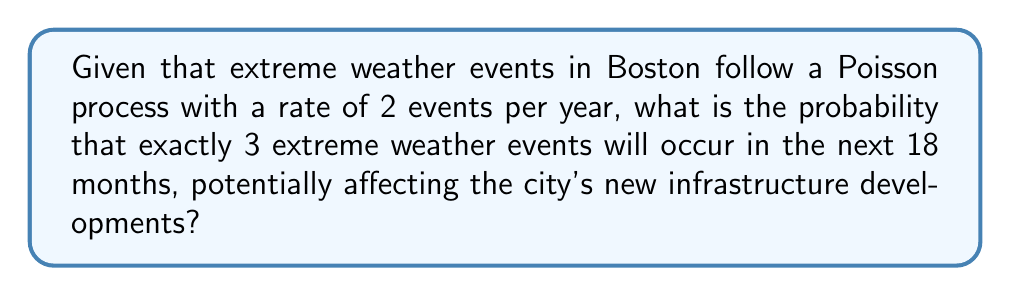Provide a solution to this math problem. Let's approach this step-by-step:

1) First, we need to adjust the rate for the given time period. The rate is 2 events per year, but we're looking at an 18-month period.

   $\lambda = 2 \text{ events/year} \times 1.5 \text{ years} = 3 \text{ events}$

2) The probability of exactly $k$ events occurring in a Poisson process is given by the formula:

   $$P(X = k) = \frac{e^{-\lambda}\lambda^k}{k!}$$

   Where $\lambda$ is the average number of events in the given time period, and $k$ is the number of events we're interested in.

3) In this case, $\lambda = 3$ and $k = 3$. Let's substitute these values:

   $$P(X = 3) = \frac{e^{-3}3^3}{3!}$$

4) Now, let's calculate:
   
   $$P(X = 3) = \frac{e^{-3} \times 27}{6}$$

5) Using a calculator for the exponential:

   $$P(X = 3) = \frac{0.0497871 \times 27}{6} = 0.2240$$

6) Therefore, the probability is approximately 0.2240 or 22.40%.
Answer: $0.2240$ or $22.40\%$ 